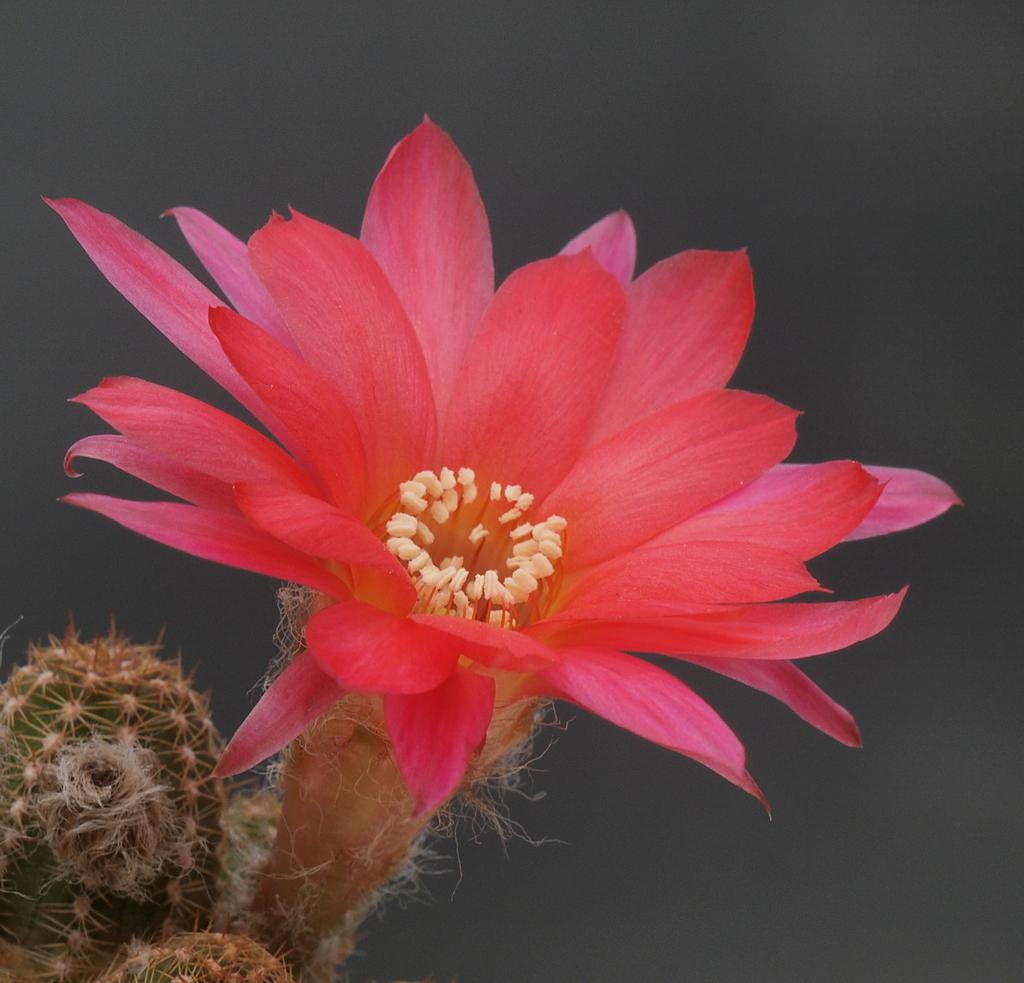What type of flower is present in the image? There is a flower in pink and cream color in the image. What other plant can be seen in the image? There is a plant in green color in the image. What color is the background of the image? The background of the image is in gray color. What shape is the car in the image? There is no car present in the image. How much salt is visible in the image? There is no salt visible in the image. 